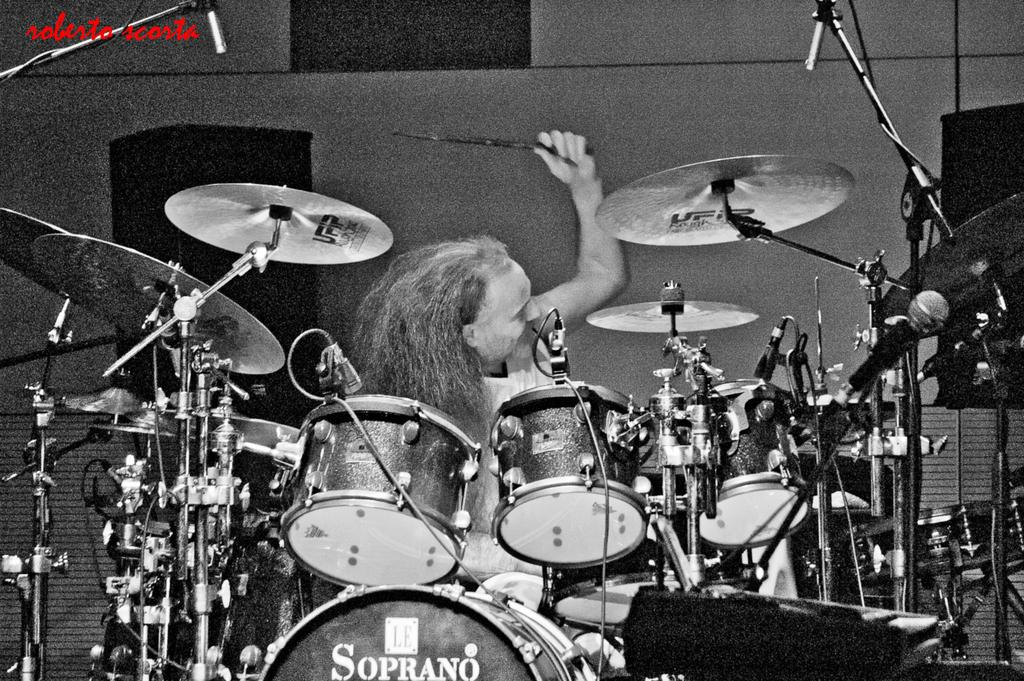What is the main activity being performed by the person in the image? The person is playing drums in the image. What is the person using to play the drums? The person is holding drumsticks. What can be seen in the front of the image? There is a band setup in the front of the image. What is visible in the background of the image? There is a wall in the background of the image. How many sheep can be seen grazing in the background of the image? There are no sheep present in the image; only a wall is visible in the background. What type of bear is playing the drums in the image? There is no bear present in the image; the person playing the drums is human. 